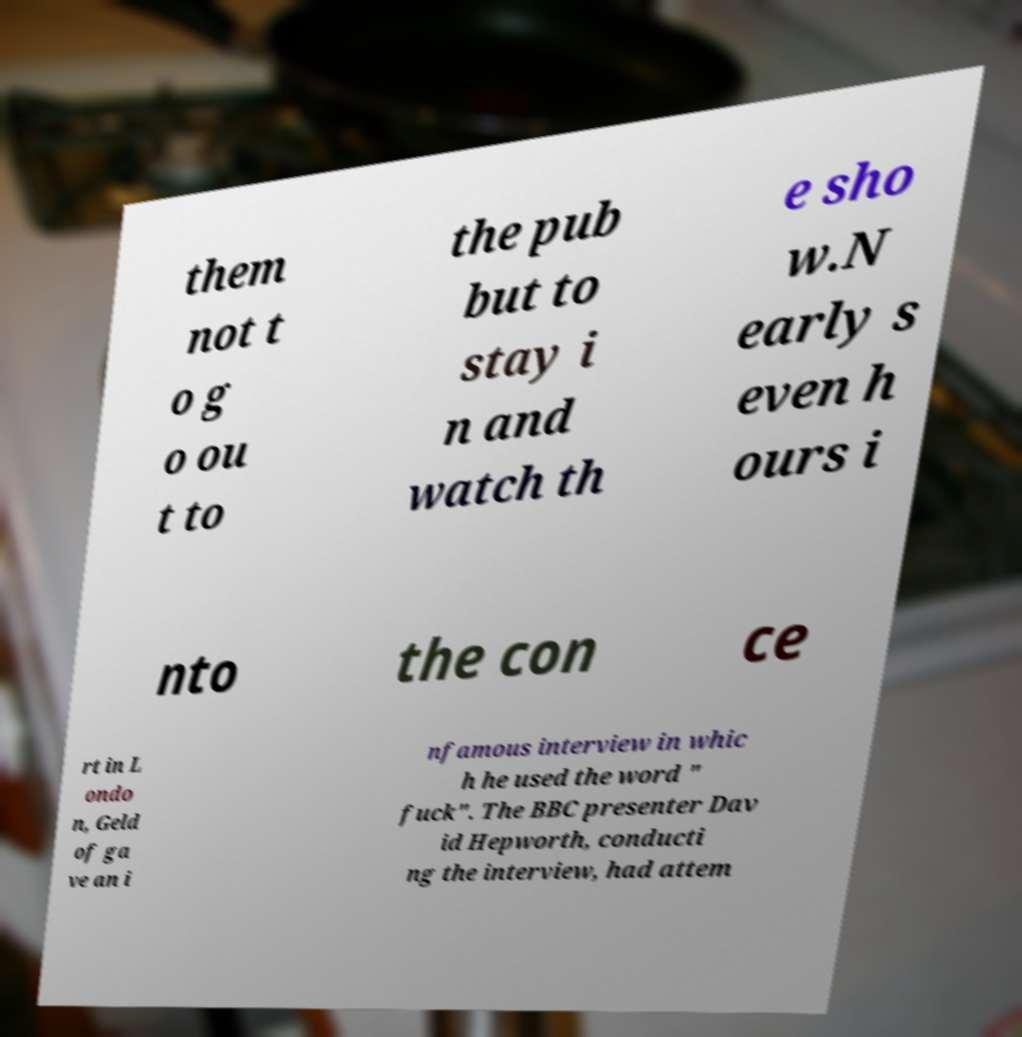Can you read and provide the text displayed in the image?This photo seems to have some interesting text. Can you extract and type it out for me? them not t o g o ou t to the pub but to stay i n and watch th e sho w.N early s even h ours i nto the con ce rt in L ondo n, Geld of ga ve an i nfamous interview in whic h he used the word " fuck". The BBC presenter Dav id Hepworth, conducti ng the interview, had attem 